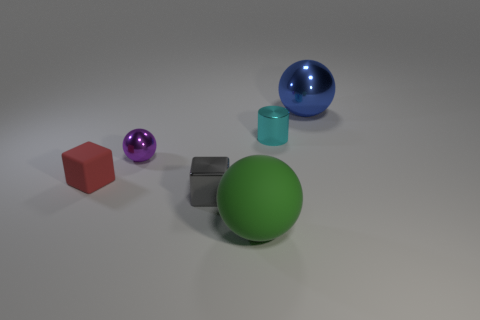How many large objects are either blue metallic things or shiny cylinders?
Offer a terse response. 1. Are there any other things that have the same color as the small shiny cube?
Provide a short and direct response. No. What shape is the tiny purple thing that is made of the same material as the tiny cylinder?
Provide a succinct answer. Sphere. What size is the shiny ball that is to the left of the tiny cyan shiny object?
Make the answer very short. Small. The small gray shiny thing is what shape?
Ensure brevity in your answer.  Cube. There is a ball that is on the right side of the green matte thing; is its size the same as the metallic ball that is on the left side of the large green rubber sphere?
Make the answer very short. No. There is a metal ball left of the sphere that is behind the small thing on the right side of the green rubber thing; how big is it?
Give a very brief answer. Small. What shape is the big thing in front of the large thing right of the big thing that is to the left of the large metallic object?
Offer a terse response. Sphere. What is the shape of the metal thing that is in front of the small red thing?
Your answer should be very brief. Cube. Do the red cube and the large sphere behind the gray metallic thing have the same material?
Give a very brief answer. No. 